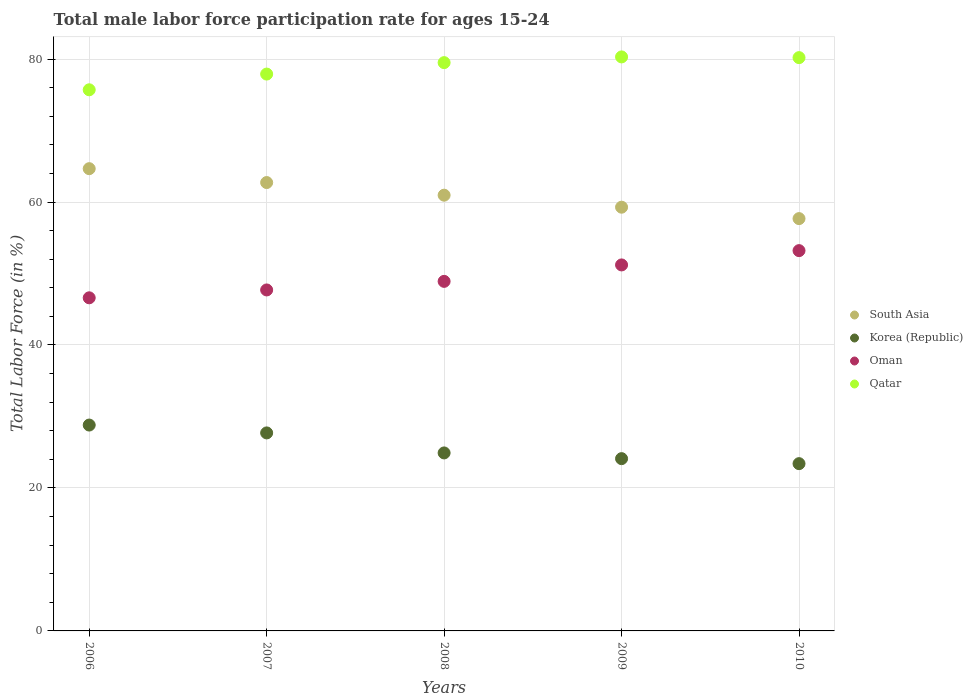How many different coloured dotlines are there?
Offer a very short reply. 4. What is the male labor force participation rate in Korea (Republic) in 2009?
Keep it short and to the point. 24.1. Across all years, what is the maximum male labor force participation rate in South Asia?
Make the answer very short. 64.67. Across all years, what is the minimum male labor force participation rate in South Asia?
Provide a short and direct response. 57.68. In which year was the male labor force participation rate in Oman minimum?
Make the answer very short. 2006. What is the total male labor force participation rate in South Asia in the graph?
Offer a very short reply. 305.3. What is the difference between the male labor force participation rate in South Asia in 2006 and that in 2010?
Give a very brief answer. 6.99. What is the difference between the male labor force participation rate in Qatar in 2006 and the male labor force participation rate in South Asia in 2008?
Offer a very short reply. 14.74. What is the average male labor force participation rate in Oman per year?
Provide a short and direct response. 49.52. In the year 2010, what is the difference between the male labor force participation rate in Korea (Republic) and male labor force participation rate in Qatar?
Provide a succinct answer. -56.8. In how many years, is the male labor force participation rate in Korea (Republic) greater than 4 %?
Give a very brief answer. 5. What is the ratio of the male labor force participation rate in Oman in 2006 to that in 2010?
Make the answer very short. 0.88. What is the difference between the highest and the second highest male labor force participation rate in Oman?
Your answer should be compact. 2. What is the difference between the highest and the lowest male labor force participation rate in Oman?
Your answer should be compact. 6.6. Is it the case that in every year, the sum of the male labor force participation rate in Korea (Republic) and male labor force participation rate in South Asia  is greater than the male labor force participation rate in Oman?
Offer a terse response. Yes. Is the male labor force participation rate in Oman strictly less than the male labor force participation rate in South Asia over the years?
Your response must be concise. Yes. How many dotlines are there?
Provide a short and direct response. 4. What is the difference between two consecutive major ticks on the Y-axis?
Give a very brief answer. 20. Are the values on the major ticks of Y-axis written in scientific E-notation?
Offer a terse response. No. Does the graph contain any zero values?
Offer a terse response. No. Does the graph contain grids?
Ensure brevity in your answer.  Yes. Where does the legend appear in the graph?
Ensure brevity in your answer.  Center right. How many legend labels are there?
Your answer should be compact. 4. How are the legend labels stacked?
Ensure brevity in your answer.  Vertical. What is the title of the graph?
Your answer should be compact. Total male labor force participation rate for ages 15-24. Does "Zimbabwe" appear as one of the legend labels in the graph?
Ensure brevity in your answer.  No. What is the label or title of the Y-axis?
Ensure brevity in your answer.  Total Labor Force (in %). What is the Total Labor Force (in %) of South Asia in 2006?
Offer a very short reply. 64.67. What is the Total Labor Force (in %) in Korea (Republic) in 2006?
Keep it short and to the point. 28.8. What is the Total Labor Force (in %) of Oman in 2006?
Give a very brief answer. 46.6. What is the Total Labor Force (in %) in Qatar in 2006?
Give a very brief answer. 75.7. What is the Total Labor Force (in %) of South Asia in 2007?
Provide a succinct answer. 62.72. What is the Total Labor Force (in %) of Korea (Republic) in 2007?
Your answer should be very brief. 27.7. What is the Total Labor Force (in %) of Oman in 2007?
Keep it short and to the point. 47.7. What is the Total Labor Force (in %) in Qatar in 2007?
Ensure brevity in your answer.  77.9. What is the Total Labor Force (in %) in South Asia in 2008?
Give a very brief answer. 60.96. What is the Total Labor Force (in %) in Korea (Republic) in 2008?
Ensure brevity in your answer.  24.9. What is the Total Labor Force (in %) in Oman in 2008?
Offer a terse response. 48.9. What is the Total Labor Force (in %) of Qatar in 2008?
Provide a succinct answer. 79.5. What is the Total Labor Force (in %) in South Asia in 2009?
Your response must be concise. 59.28. What is the Total Labor Force (in %) in Korea (Republic) in 2009?
Your response must be concise. 24.1. What is the Total Labor Force (in %) of Oman in 2009?
Give a very brief answer. 51.2. What is the Total Labor Force (in %) in Qatar in 2009?
Keep it short and to the point. 80.3. What is the Total Labor Force (in %) of South Asia in 2010?
Your answer should be very brief. 57.68. What is the Total Labor Force (in %) in Korea (Republic) in 2010?
Keep it short and to the point. 23.4. What is the Total Labor Force (in %) in Oman in 2010?
Provide a succinct answer. 53.2. What is the Total Labor Force (in %) in Qatar in 2010?
Offer a terse response. 80.2. Across all years, what is the maximum Total Labor Force (in %) in South Asia?
Your response must be concise. 64.67. Across all years, what is the maximum Total Labor Force (in %) in Korea (Republic)?
Your answer should be very brief. 28.8. Across all years, what is the maximum Total Labor Force (in %) of Oman?
Provide a short and direct response. 53.2. Across all years, what is the maximum Total Labor Force (in %) of Qatar?
Ensure brevity in your answer.  80.3. Across all years, what is the minimum Total Labor Force (in %) of South Asia?
Provide a short and direct response. 57.68. Across all years, what is the minimum Total Labor Force (in %) in Korea (Republic)?
Make the answer very short. 23.4. Across all years, what is the minimum Total Labor Force (in %) in Oman?
Provide a short and direct response. 46.6. Across all years, what is the minimum Total Labor Force (in %) of Qatar?
Make the answer very short. 75.7. What is the total Total Labor Force (in %) of South Asia in the graph?
Your answer should be very brief. 305.3. What is the total Total Labor Force (in %) of Korea (Republic) in the graph?
Keep it short and to the point. 128.9. What is the total Total Labor Force (in %) of Oman in the graph?
Your answer should be compact. 247.6. What is the total Total Labor Force (in %) in Qatar in the graph?
Offer a terse response. 393.6. What is the difference between the Total Labor Force (in %) of South Asia in 2006 and that in 2007?
Offer a very short reply. 1.94. What is the difference between the Total Labor Force (in %) of South Asia in 2006 and that in 2008?
Provide a succinct answer. 3.71. What is the difference between the Total Labor Force (in %) of Oman in 2006 and that in 2008?
Your response must be concise. -2.3. What is the difference between the Total Labor Force (in %) of South Asia in 2006 and that in 2009?
Make the answer very short. 5.39. What is the difference between the Total Labor Force (in %) of Korea (Republic) in 2006 and that in 2009?
Give a very brief answer. 4.7. What is the difference between the Total Labor Force (in %) in Qatar in 2006 and that in 2009?
Your response must be concise. -4.6. What is the difference between the Total Labor Force (in %) in South Asia in 2006 and that in 2010?
Your response must be concise. 6.99. What is the difference between the Total Labor Force (in %) of Korea (Republic) in 2006 and that in 2010?
Make the answer very short. 5.4. What is the difference between the Total Labor Force (in %) of Qatar in 2006 and that in 2010?
Your answer should be compact. -4.5. What is the difference between the Total Labor Force (in %) of South Asia in 2007 and that in 2008?
Your answer should be very brief. 1.77. What is the difference between the Total Labor Force (in %) in Oman in 2007 and that in 2008?
Your answer should be very brief. -1.2. What is the difference between the Total Labor Force (in %) in South Asia in 2007 and that in 2009?
Ensure brevity in your answer.  3.45. What is the difference between the Total Labor Force (in %) of Korea (Republic) in 2007 and that in 2009?
Provide a succinct answer. 3.6. What is the difference between the Total Labor Force (in %) of Qatar in 2007 and that in 2009?
Provide a succinct answer. -2.4. What is the difference between the Total Labor Force (in %) in South Asia in 2007 and that in 2010?
Keep it short and to the point. 5.04. What is the difference between the Total Labor Force (in %) in South Asia in 2008 and that in 2009?
Keep it short and to the point. 1.68. What is the difference between the Total Labor Force (in %) in Korea (Republic) in 2008 and that in 2009?
Offer a very short reply. 0.8. What is the difference between the Total Labor Force (in %) of South Asia in 2008 and that in 2010?
Your answer should be compact. 3.28. What is the difference between the Total Labor Force (in %) of Qatar in 2008 and that in 2010?
Offer a very short reply. -0.7. What is the difference between the Total Labor Force (in %) of South Asia in 2009 and that in 2010?
Your answer should be compact. 1.6. What is the difference between the Total Labor Force (in %) in Korea (Republic) in 2009 and that in 2010?
Ensure brevity in your answer.  0.7. What is the difference between the Total Labor Force (in %) in Qatar in 2009 and that in 2010?
Offer a terse response. 0.1. What is the difference between the Total Labor Force (in %) in South Asia in 2006 and the Total Labor Force (in %) in Korea (Republic) in 2007?
Provide a succinct answer. 36.97. What is the difference between the Total Labor Force (in %) in South Asia in 2006 and the Total Labor Force (in %) in Oman in 2007?
Offer a terse response. 16.97. What is the difference between the Total Labor Force (in %) in South Asia in 2006 and the Total Labor Force (in %) in Qatar in 2007?
Provide a short and direct response. -13.23. What is the difference between the Total Labor Force (in %) of Korea (Republic) in 2006 and the Total Labor Force (in %) of Oman in 2007?
Keep it short and to the point. -18.9. What is the difference between the Total Labor Force (in %) in Korea (Republic) in 2006 and the Total Labor Force (in %) in Qatar in 2007?
Provide a succinct answer. -49.1. What is the difference between the Total Labor Force (in %) in Oman in 2006 and the Total Labor Force (in %) in Qatar in 2007?
Offer a very short reply. -31.3. What is the difference between the Total Labor Force (in %) of South Asia in 2006 and the Total Labor Force (in %) of Korea (Republic) in 2008?
Give a very brief answer. 39.77. What is the difference between the Total Labor Force (in %) in South Asia in 2006 and the Total Labor Force (in %) in Oman in 2008?
Provide a succinct answer. 15.77. What is the difference between the Total Labor Force (in %) in South Asia in 2006 and the Total Labor Force (in %) in Qatar in 2008?
Provide a succinct answer. -14.83. What is the difference between the Total Labor Force (in %) of Korea (Republic) in 2006 and the Total Labor Force (in %) of Oman in 2008?
Offer a very short reply. -20.1. What is the difference between the Total Labor Force (in %) of Korea (Republic) in 2006 and the Total Labor Force (in %) of Qatar in 2008?
Keep it short and to the point. -50.7. What is the difference between the Total Labor Force (in %) in Oman in 2006 and the Total Labor Force (in %) in Qatar in 2008?
Ensure brevity in your answer.  -32.9. What is the difference between the Total Labor Force (in %) in South Asia in 2006 and the Total Labor Force (in %) in Korea (Republic) in 2009?
Offer a terse response. 40.57. What is the difference between the Total Labor Force (in %) in South Asia in 2006 and the Total Labor Force (in %) in Oman in 2009?
Make the answer very short. 13.47. What is the difference between the Total Labor Force (in %) of South Asia in 2006 and the Total Labor Force (in %) of Qatar in 2009?
Your answer should be compact. -15.63. What is the difference between the Total Labor Force (in %) of Korea (Republic) in 2006 and the Total Labor Force (in %) of Oman in 2009?
Offer a terse response. -22.4. What is the difference between the Total Labor Force (in %) in Korea (Republic) in 2006 and the Total Labor Force (in %) in Qatar in 2009?
Make the answer very short. -51.5. What is the difference between the Total Labor Force (in %) in Oman in 2006 and the Total Labor Force (in %) in Qatar in 2009?
Your answer should be compact. -33.7. What is the difference between the Total Labor Force (in %) of South Asia in 2006 and the Total Labor Force (in %) of Korea (Republic) in 2010?
Keep it short and to the point. 41.27. What is the difference between the Total Labor Force (in %) of South Asia in 2006 and the Total Labor Force (in %) of Oman in 2010?
Offer a terse response. 11.47. What is the difference between the Total Labor Force (in %) of South Asia in 2006 and the Total Labor Force (in %) of Qatar in 2010?
Your answer should be very brief. -15.53. What is the difference between the Total Labor Force (in %) of Korea (Republic) in 2006 and the Total Labor Force (in %) of Oman in 2010?
Your answer should be very brief. -24.4. What is the difference between the Total Labor Force (in %) of Korea (Republic) in 2006 and the Total Labor Force (in %) of Qatar in 2010?
Make the answer very short. -51.4. What is the difference between the Total Labor Force (in %) in Oman in 2006 and the Total Labor Force (in %) in Qatar in 2010?
Your answer should be compact. -33.6. What is the difference between the Total Labor Force (in %) of South Asia in 2007 and the Total Labor Force (in %) of Korea (Republic) in 2008?
Provide a short and direct response. 37.82. What is the difference between the Total Labor Force (in %) of South Asia in 2007 and the Total Labor Force (in %) of Oman in 2008?
Give a very brief answer. 13.82. What is the difference between the Total Labor Force (in %) of South Asia in 2007 and the Total Labor Force (in %) of Qatar in 2008?
Provide a short and direct response. -16.78. What is the difference between the Total Labor Force (in %) in Korea (Republic) in 2007 and the Total Labor Force (in %) in Oman in 2008?
Your response must be concise. -21.2. What is the difference between the Total Labor Force (in %) in Korea (Republic) in 2007 and the Total Labor Force (in %) in Qatar in 2008?
Give a very brief answer. -51.8. What is the difference between the Total Labor Force (in %) of Oman in 2007 and the Total Labor Force (in %) of Qatar in 2008?
Provide a short and direct response. -31.8. What is the difference between the Total Labor Force (in %) of South Asia in 2007 and the Total Labor Force (in %) of Korea (Republic) in 2009?
Make the answer very short. 38.62. What is the difference between the Total Labor Force (in %) of South Asia in 2007 and the Total Labor Force (in %) of Oman in 2009?
Offer a very short reply. 11.52. What is the difference between the Total Labor Force (in %) in South Asia in 2007 and the Total Labor Force (in %) in Qatar in 2009?
Ensure brevity in your answer.  -17.58. What is the difference between the Total Labor Force (in %) of Korea (Republic) in 2007 and the Total Labor Force (in %) of Oman in 2009?
Your answer should be very brief. -23.5. What is the difference between the Total Labor Force (in %) of Korea (Republic) in 2007 and the Total Labor Force (in %) of Qatar in 2009?
Your answer should be very brief. -52.6. What is the difference between the Total Labor Force (in %) in Oman in 2007 and the Total Labor Force (in %) in Qatar in 2009?
Make the answer very short. -32.6. What is the difference between the Total Labor Force (in %) of South Asia in 2007 and the Total Labor Force (in %) of Korea (Republic) in 2010?
Keep it short and to the point. 39.32. What is the difference between the Total Labor Force (in %) in South Asia in 2007 and the Total Labor Force (in %) in Oman in 2010?
Offer a terse response. 9.52. What is the difference between the Total Labor Force (in %) of South Asia in 2007 and the Total Labor Force (in %) of Qatar in 2010?
Provide a succinct answer. -17.48. What is the difference between the Total Labor Force (in %) in Korea (Republic) in 2007 and the Total Labor Force (in %) in Oman in 2010?
Keep it short and to the point. -25.5. What is the difference between the Total Labor Force (in %) of Korea (Republic) in 2007 and the Total Labor Force (in %) of Qatar in 2010?
Provide a succinct answer. -52.5. What is the difference between the Total Labor Force (in %) of Oman in 2007 and the Total Labor Force (in %) of Qatar in 2010?
Offer a terse response. -32.5. What is the difference between the Total Labor Force (in %) of South Asia in 2008 and the Total Labor Force (in %) of Korea (Republic) in 2009?
Your answer should be compact. 36.86. What is the difference between the Total Labor Force (in %) of South Asia in 2008 and the Total Labor Force (in %) of Oman in 2009?
Keep it short and to the point. 9.76. What is the difference between the Total Labor Force (in %) in South Asia in 2008 and the Total Labor Force (in %) in Qatar in 2009?
Your answer should be compact. -19.34. What is the difference between the Total Labor Force (in %) in Korea (Republic) in 2008 and the Total Labor Force (in %) in Oman in 2009?
Make the answer very short. -26.3. What is the difference between the Total Labor Force (in %) in Korea (Republic) in 2008 and the Total Labor Force (in %) in Qatar in 2009?
Ensure brevity in your answer.  -55.4. What is the difference between the Total Labor Force (in %) in Oman in 2008 and the Total Labor Force (in %) in Qatar in 2009?
Offer a terse response. -31.4. What is the difference between the Total Labor Force (in %) of South Asia in 2008 and the Total Labor Force (in %) of Korea (Republic) in 2010?
Make the answer very short. 37.56. What is the difference between the Total Labor Force (in %) in South Asia in 2008 and the Total Labor Force (in %) in Oman in 2010?
Provide a short and direct response. 7.76. What is the difference between the Total Labor Force (in %) of South Asia in 2008 and the Total Labor Force (in %) of Qatar in 2010?
Your answer should be very brief. -19.24. What is the difference between the Total Labor Force (in %) in Korea (Republic) in 2008 and the Total Labor Force (in %) in Oman in 2010?
Your response must be concise. -28.3. What is the difference between the Total Labor Force (in %) in Korea (Republic) in 2008 and the Total Labor Force (in %) in Qatar in 2010?
Provide a short and direct response. -55.3. What is the difference between the Total Labor Force (in %) of Oman in 2008 and the Total Labor Force (in %) of Qatar in 2010?
Make the answer very short. -31.3. What is the difference between the Total Labor Force (in %) of South Asia in 2009 and the Total Labor Force (in %) of Korea (Republic) in 2010?
Ensure brevity in your answer.  35.88. What is the difference between the Total Labor Force (in %) of South Asia in 2009 and the Total Labor Force (in %) of Oman in 2010?
Your answer should be very brief. 6.08. What is the difference between the Total Labor Force (in %) of South Asia in 2009 and the Total Labor Force (in %) of Qatar in 2010?
Your answer should be compact. -20.92. What is the difference between the Total Labor Force (in %) in Korea (Republic) in 2009 and the Total Labor Force (in %) in Oman in 2010?
Make the answer very short. -29.1. What is the difference between the Total Labor Force (in %) in Korea (Republic) in 2009 and the Total Labor Force (in %) in Qatar in 2010?
Your answer should be compact. -56.1. What is the difference between the Total Labor Force (in %) of Oman in 2009 and the Total Labor Force (in %) of Qatar in 2010?
Offer a terse response. -29. What is the average Total Labor Force (in %) of South Asia per year?
Provide a short and direct response. 61.06. What is the average Total Labor Force (in %) of Korea (Republic) per year?
Your response must be concise. 25.78. What is the average Total Labor Force (in %) of Oman per year?
Your answer should be compact. 49.52. What is the average Total Labor Force (in %) of Qatar per year?
Your answer should be very brief. 78.72. In the year 2006, what is the difference between the Total Labor Force (in %) in South Asia and Total Labor Force (in %) in Korea (Republic)?
Your answer should be very brief. 35.87. In the year 2006, what is the difference between the Total Labor Force (in %) in South Asia and Total Labor Force (in %) in Oman?
Your answer should be very brief. 18.07. In the year 2006, what is the difference between the Total Labor Force (in %) in South Asia and Total Labor Force (in %) in Qatar?
Your answer should be compact. -11.03. In the year 2006, what is the difference between the Total Labor Force (in %) of Korea (Republic) and Total Labor Force (in %) of Oman?
Keep it short and to the point. -17.8. In the year 2006, what is the difference between the Total Labor Force (in %) in Korea (Republic) and Total Labor Force (in %) in Qatar?
Your answer should be compact. -46.9. In the year 2006, what is the difference between the Total Labor Force (in %) of Oman and Total Labor Force (in %) of Qatar?
Offer a terse response. -29.1. In the year 2007, what is the difference between the Total Labor Force (in %) in South Asia and Total Labor Force (in %) in Korea (Republic)?
Keep it short and to the point. 35.02. In the year 2007, what is the difference between the Total Labor Force (in %) of South Asia and Total Labor Force (in %) of Oman?
Your answer should be compact. 15.02. In the year 2007, what is the difference between the Total Labor Force (in %) of South Asia and Total Labor Force (in %) of Qatar?
Your answer should be compact. -15.18. In the year 2007, what is the difference between the Total Labor Force (in %) in Korea (Republic) and Total Labor Force (in %) in Qatar?
Your answer should be compact. -50.2. In the year 2007, what is the difference between the Total Labor Force (in %) in Oman and Total Labor Force (in %) in Qatar?
Your answer should be compact. -30.2. In the year 2008, what is the difference between the Total Labor Force (in %) of South Asia and Total Labor Force (in %) of Korea (Republic)?
Give a very brief answer. 36.06. In the year 2008, what is the difference between the Total Labor Force (in %) in South Asia and Total Labor Force (in %) in Oman?
Offer a very short reply. 12.06. In the year 2008, what is the difference between the Total Labor Force (in %) of South Asia and Total Labor Force (in %) of Qatar?
Provide a short and direct response. -18.54. In the year 2008, what is the difference between the Total Labor Force (in %) of Korea (Republic) and Total Labor Force (in %) of Oman?
Provide a succinct answer. -24. In the year 2008, what is the difference between the Total Labor Force (in %) in Korea (Republic) and Total Labor Force (in %) in Qatar?
Make the answer very short. -54.6. In the year 2008, what is the difference between the Total Labor Force (in %) of Oman and Total Labor Force (in %) of Qatar?
Offer a terse response. -30.6. In the year 2009, what is the difference between the Total Labor Force (in %) in South Asia and Total Labor Force (in %) in Korea (Republic)?
Your answer should be very brief. 35.18. In the year 2009, what is the difference between the Total Labor Force (in %) of South Asia and Total Labor Force (in %) of Oman?
Your answer should be very brief. 8.08. In the year 2009, what is the difference between the Total Labor Force (in %) in South Asia and Total Labor Force (in %) in Qatar?
Provide a short and direct response. -21.02. In the year 2009, what is the difference between the Total Labor Force (in %) in Korea (Republic) and Total Labor Force (in %) in Oman?
Your answer should be compact. -27.1. In the year 2009, what is the difference between the Total Labor Force (in %) of Korea (Republic) and Total Labor Force (in %) of Qatar?
Provide a succinct answer. -56.2. In the year 2009, what is the difference between the Total Labor Force (in %) of Oman and Total Labor Force (in %) of Qatar?
Ensure brevity in your answer.  -29.1. In the year 2010, what is the difference between the Total Labor Force (in %) in South Asia and Total Labor Force (in %) in Korea (Republic)?
Offer a very short reply. 34.28. In the year 2010, what is the difference between the Total Labor Force (in %) in South Asia and Total Labor Force (in %) in Oman?
Ensure brevity in your answer.  4.48. In the year 2010, what is the difference between the Total Labor Force (in %) in South Asia and Total Labor Force (in %) in Qatar?
Offer a very short reply. -22.52. In the year 2010, what is the difference between the Total Labor Force (in %) of Korea (Republic) and Total Labor Force (in %) of Oman?
Your answer should be compact. -29.8. In the year 2010, what is the difference between the Total Labor Force (in %) of Korea (Republic) and Total Labor Force (in %) of Qatar?
Make the answer very short. -56.8. What is the ratio of the Total Labor Force (in %) of South Asia in 2006 to that in 2007?
Your response must be concise. 1.03. What is the ratio of the Total Labor Force (in %) of Korea (Republic) in 2006 to that in 2007?
Provide a short and direct response. 1.04. What is the ratio of the Total Labor Force (in %) of Oman in 2006 to that in 2007?
Your response must be concise. 0.98. What is the ratio of the Total Labor Force (in %) of Qatar in 2006 to that in 2007?
Offer a very short reply. 0.97. What is the ratio of the Total Labor Force (in %) of South Asia in 2006 to that in 2008?
Ensure brevity in your answer.  1.06. What is the ratio of the Total Labor Force (in %) in Korea (Republic) in 2006 to that in 2008?
Make the answer very short. 1.16. What is the ratio of the Total Labor Force (in %) of Oman in 2006 to that in 2008?
Provide a short and direct response. 0.95. What is the ratio of the Total Labor Force (in %) in Qatar in 2006 to that in 2008?
Your response must be concise. 0.95. What is the ratio of the Total Labor Force (in %) in Korea (Republic) in 2006 to that in 2009?
Provide a succinct answer. 1.2. What is the ratio of the Total Labor Force (in %) in Oman in 2006 to that in 2009?
Keep it short and to the point. 0.91. What is the ratio of the Total Labor Force (in %) of Qatar in 2006 to that in 2009?
Offer a terse response. 0.94. What is the ratio of the Total Labor Force (in %) of South Asia in 2006 to that in 2010?
Make the answer very short. 1.12. What is the ratio of the Total Labor Force (in %) in Korea (Republic) in 2006 to that in 2010?
Offer a terse response. 1.23. What is the ratio of the Total Labor Force (in %) in Oman in 2006 to that in 2010?
Keep it short and to the point. 0.88. What is the ratio of the Total Labor Force (in %) of Qatar in 2006 to that in 2010?
Offer a terse response. 0.94. What is the ratio of the Total Labor Force (in %) in South Asia in 2007 to that in 2008?
Offer a very short reply. 1.03. What is the ratio of the Total Labor Force (in %) in Korea (Republic) in 2007 to that in 2008?
Provide a short and direct response. 1.11. What is the ratio of the Total Labor Force (in %) in Oman in 2007 to that in 2008?
Provide a short and direct response. 0.98. What is the ratio of the Total Labor Force (in %) in Qatar in 2007 to that in 2008?
Give a very brief answer. 0.98. What is the ratio of the Total Labor Force (in %) of South Asia in 2007 to that in 2009?
Provide a short and direct response. 1.06. What is the ratio of the Total Labor Force (in %) of Korea (Republic) in 2007 to that in 2009?
Your response must be concise. 1.15. What is the ratio of the Total Labor Force (in %) in Oman in 2007 to that in 2009?
Keep it short and to the point. 0.93. What is the ratio of the Total Labor Force (in %) in Qatar in 2007 to that in 2009?
Give a very brief answer. 0.97. What is the ratio of the Total Labor Force (in %) of South Asia in 2007 to that in 2010?
Your answer should be compact. 1.09. What is the ratio of the Total Labor Force (in %) in Korea (Republic) in 2007 to that in 2010?
Offer a very short reply. 1.18. What is the ratio of the Total Labor Force (in %) in Oman in 2007 to that in 2010?
Make the answer very short. 0.9. What is the ratio of the Total Labor Force (in %) in Qatar in 2007 to that in 2010?
Keep it short and to the point. 0.97. What is the ratio of the Total Labor Force (in %) of South Asia in 2008 to that in 2009?
Your answer should be compact. 1.03. What is the ratio of the Total Labor Force (in %) in Korea (Republic) in 2008 to that in 2009?
Provide a succinct answer. 1.03. What is the ratio of the Total Labor Force (in %) of Oman in 2008 to that in 2009?
Ensure brevity in your answer.  0.96. What is the ratio of the Total Labor Force (in %) in Qatar in 2008 to that in 2009?
Your answer should be very brief. 0.99. What is the ratio of the Total Labor Force (in %) of South Asia in 2008 to that in 2010?
Ensure brevity in your answer.  1.06. What is the ratio of the Total Labor Force (in %) in Korea (Republic) in 2008 to that in 2010?
Provide a succinct answer. 1.06. What is the ratio of the Total Labor Force (in %) in Oman in 2008 to that in 2010?
Your answer should be compact. 0.92. What is the ratio of the Total Labor Force (in %) of Qatar in 2008 to that in 2010?
Give a very brief answer. 0.99. What is the ratio of the Total Labor Force (in %) in South Asia in 2009 to that in 2010?
Offer a terse response. 1.03. What is the ratio of the Total Labor Force (in %) in Korea (Republic) in 2009 to that in 2010?
Your answer should be very brief. 1.03. What is the ratio of the Total Labor Force (in %) in Oman in 2009 to that in 2010?
Keep it short and to the point. 0.96. What is the difference between the highest and the second highest Total Labor Force (in %) in South Asia?
Your answer should be compact. 1.94. What is the difference between the highest and the second highest Total Labor Force (in %) in Qatar?
Keep it short and to the point. 0.1. What is the difference between the highest and the lowest Total Labor Force (in %) of South Asia?
Ensure brevity in your answer.  6.99. What is the difference between the highest and the lowest Total Labor Force (in %) of Oman?
Offer a very short reply. 6.6. 